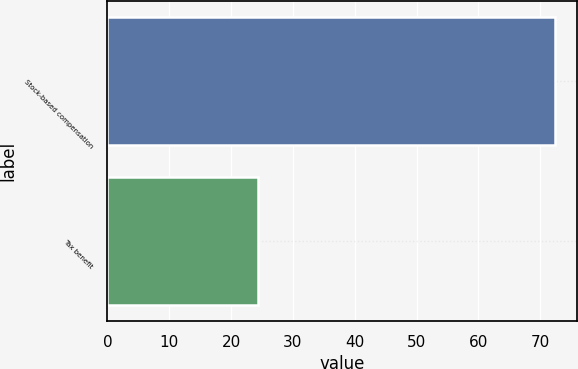Convert chart to OTSL. <chart><loc_0><loc_0><loc_500><loc_500><bar_chart><fcel>Stock-based compensation<fcel>Tax benefit<nl><fcel>72.3<fcel>24.4<nl></chart> 